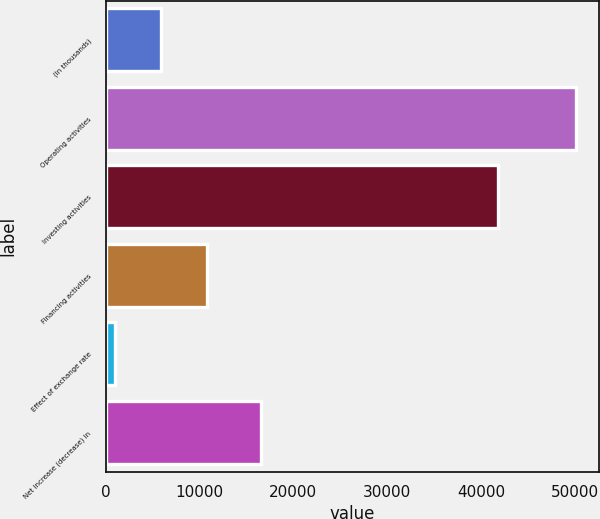Convert chart. <chart><loc_0><loc_0><loc_500><loc_500><bar_chart><fcel>(In thousands)<fcel>Operating activities<fcel>Investing activities<fcel>Financing activities<fcel>Effect of exchange rate<fcel>Net increase (decrease) in<nl><fcel>5912.3<fcel>50114<fcel>41785<fcel>10823.6<fcel>1001<fcel>16573<nl></chart> 